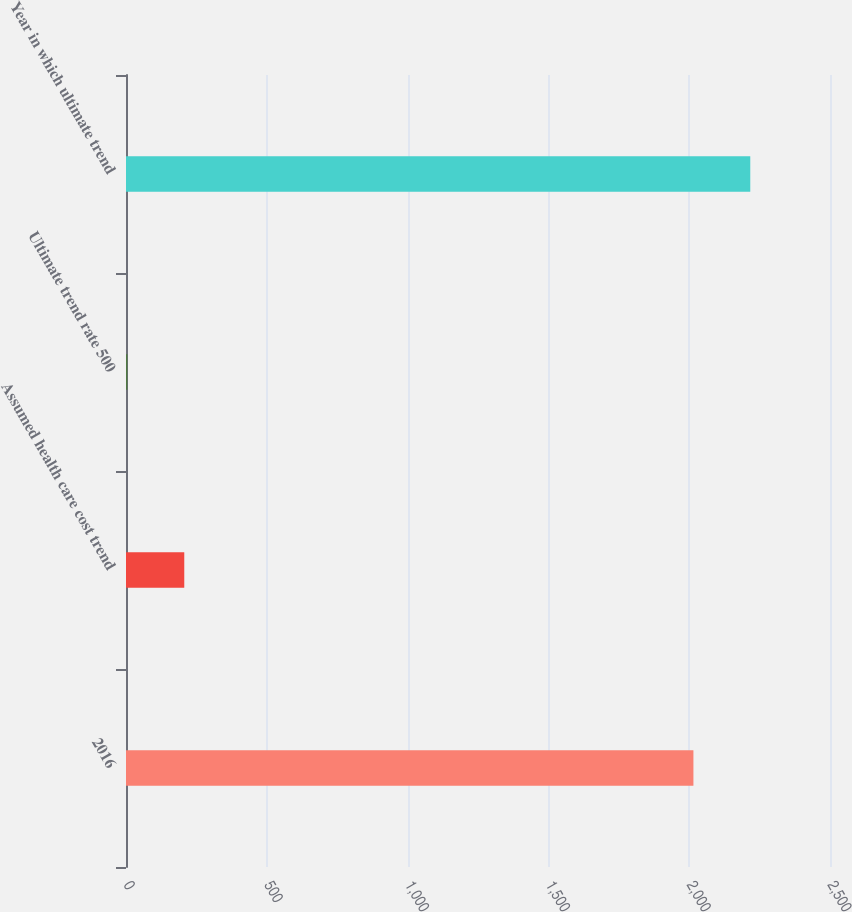<chart> <loc_0><loc_0><loc_500><loc_500><bar_chart><fcel>2016<fcel>Assumed health care cost trend<fcel>Ultimate trend rate 500<fcel>Year in which ultimate trend<nl><fcel>2015<fcel>206.9<fcel>5<fcel>2216.9<nl></chart> 